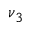Convert formula to latex. <formula><loc_0><loc_0><loc_500><loc_500>\nu _ { 3 }</formula> 